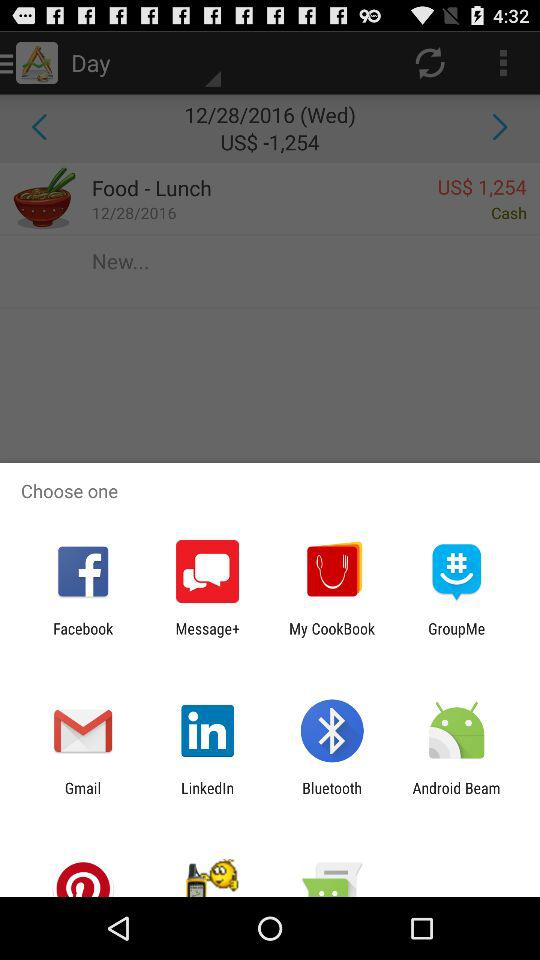What is the difference between the amounts of money in the two transactions?
Answer the question using a single word or phrase. -2508 